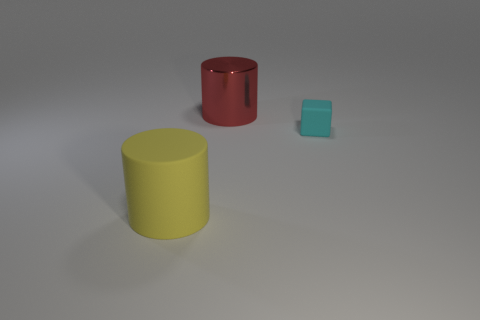What can you infer about the size of the objects relative to each other? Relative to each other, the yellow cylinder is the largest object, the red cylinder is medium-sized, and the blue cube is the smallest. The size differences suggest a range of volumes and proportions among the objects. 